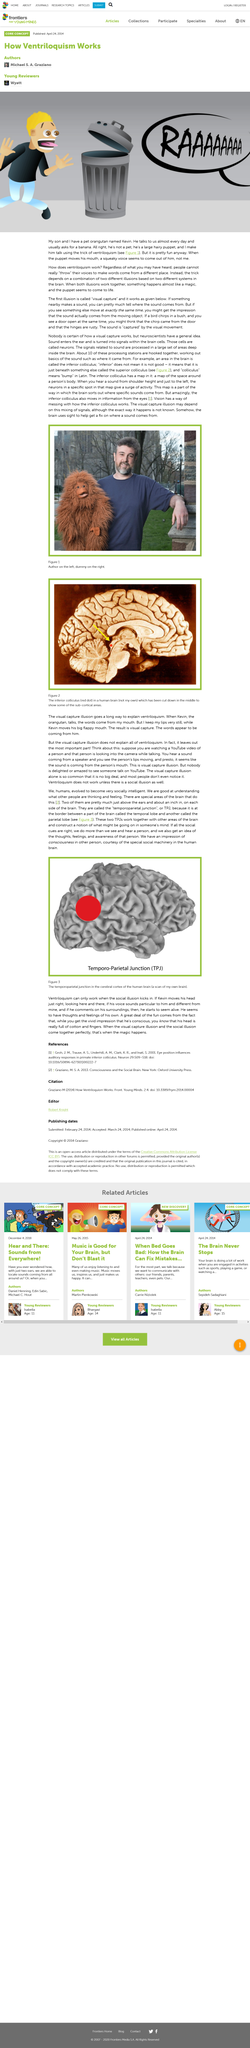Outline some significant characteristics in this image. The Temporo-Parietal Junction, commonly abbreviated as TPJ, is a region of the brain that plays a critical role in various cognitive and emotional processes, including social cognition, self-awareness, and decision-making. Colliculus," meaning "bump" in Latin, is a word that refers to a small, rounded elevation or protrusion. In the context of anatomy or medicine, it may be used to describe a bump or lump on the skin or in a bodily organ. The use of this word in Latin can help medical professionals or researchers to describe specific anatomical features, or assist in the study of the Latin language. The cells in the brain that convert sound into signals are called neurons. The man in the image is referred to as the "dummy". The Temporo-Parietal junction in the cerebral cortex is shown in the scan that is located in the area of the brain. 